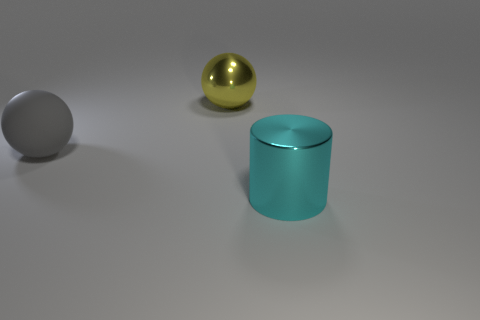What color is the large metal cylinder?
Provide a succinct answer. Cyan. Are there any other things that have the same material as the cyan cylinder?
Give a very brief answer. Yes. Is the number of shiny balls that are right of the big yellow metal thing less than the number of matte spheres to the left of the big gray matte object?
Ensure brevity in your answer.  No. What is the shape of the big thing that is in front of the large yellow shiny ball and right of the big gray object?
Keep it short and to the point. Cylinder. What number of large yellow shiny things have the same shape as the large gray thing?
Offer a very short reply. 1. There is a cylinder that is made of the same material as the yellow ball; what size is it?
Your answer should be very brief. Large. What number of other cylinders are the same size as the cyan cylinder?
Ensure brevity in your answer.  0. There is a metallic object that is behind the metallic object right of the large yellow metallic ball; what is its color?
Your answer should be very brief. Yellow. Is there a large object that has the same color as the metallic ball?
Your response must be concise. No. What is the color of the metal cylinder that is the same size as the yellow sphere?
Give a very brief answer. Cyan. 